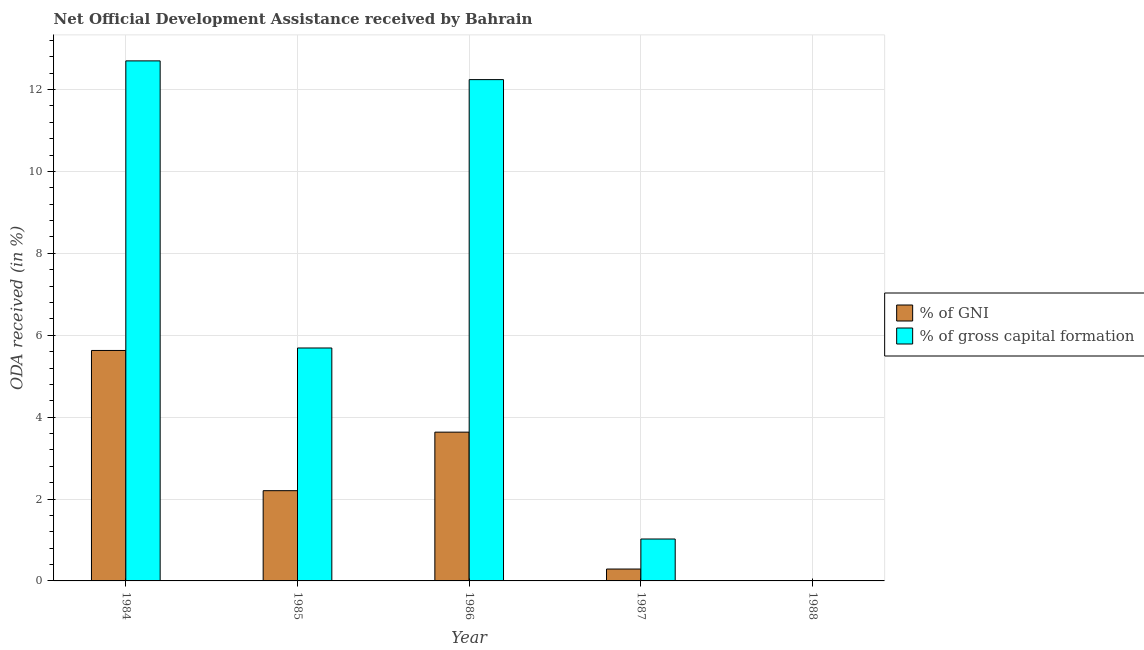How many different coloured bars are there?
Offer a terse response. 2. How many bars are there on the 1st tick from the left?
Provide a succinct answer. 2. What is the label of the 1st group of bars from the left?
Make the answer very short. 1984. In how many cases, is the number of bars for a given year not equal to the number of legend labels?
Make the answer very short. 1. Across all years, what is the maximum oda received as percentage of gross capital formation?
Offer a very short reply. 12.7. What is the total oda received as percentage of gross capital formation in the graph?
Your response must be concise. 31.66. What is the difference between the oda received as percentage of gross capital formation in 1984 and that in 1987?
Provide a short and direct response. 11.68. What is the difference between the oda received as percentage of gni in 1986 and the oda received as percentage of gross capital formation in 1987?
Offer a very short reply. 3.34. What is the average oda received as percentage of gni per year?
Your response must be concise. 2.35. What is the ratio of the oda received as percentage of gross capital formation in 1984 to that in 1987?
Your answer should be compact. 12.41. Is the difference between the oda received as percentage of gross capital formation in 1984 and 1986 greater than the difference between the oda received as percentage of gni in 1984 and 1986?
Your answer should be compact. No. What is the difference between the highest and the second highest oda received as percentage of gni?
Offer a very short reply. 2. What is the difference between the highest and the lowest oda received as percentage of gross capital formation?
Give a very brief answer. 12.7. What is the difference between two consecutive major ticks on the Y-axis?
Your answer should be very brief. 2. Are the values on the major ticks of Y-axis written in scientific E-notation?
Your answer should be very brief. No. Does the graph contain any zero values?
Provide a short and direct response. Yes. Where does the legend appear in the graph?
Your answer should be compact. Center right. How are the legend labels stacked?
Keep it short and to the point. Vertical. What is the title of the graph?
Ensure brevity in your answer.  Net Official Development Assistance received by Bahrain. Does "Females" appear as one of the legend labels in the graph?
Offer a terse response. No. What is the label or title of the X-axis?
Keep it short and to the point. Year. What is the label or title of the Y-axis?
Keep it short and to the point. ODA received (in %). What is the ODA received (in %) of % of GNI in 1984?
Your answer should be very brief. 5.63. What is the ODA received (in %) in % of gross capital formation in 1984?
Offer a terse response. 12.7. What is the ODA received (in %) in % of GNI in 1985?
Ensure brevity in your answer.  2.2. What is the ODA received (in %) of % of gross capital formation in 1985?
Provide a succinct answer. 5.69. What is the ODA received (in %) in % of GNI in 1986?
Offer a terse response. 3.63. What is the ODA received (in %) in % of gross capital formation in 1986?
Provide a succinct answer. 12.24. What is the ODA received (in %) of % of GNI in 1987?
Keep it short and to the point. 0.29. What is the ODA received (in %) in % of gross capital formation in 1987?
Make the answer very short. 1.02. What is the ODA received (in %) in % of GNI in 1988?
Your answer should be compact. 0. What is the ODA received (in %) of % of gross capital formation in 1988?
Offer a terse response. 0. Across all years, what is the maximum ODA received (in %) of % of GNI?
Your answer should be compact. 5.63. Across all years, what is the maximum ODA received (in %) in % of gross capital formation?
Your response must be concise. 12.7. Across all years, what is the minimum ODA received (in %) in % of GNI?
Offer a very short reply. 0. Across all years, what is the minimum ODA received (in %) of % of gross capital formation?
Your answer should be very brief. 0. What is the total ODA received (in %) of % of GNI in the graph?
Offer a terse response. 11.76. What is the total ODA received (in %) of % of gross capital formation in the graph?
Your response must be concise. 31.66. What is the difference between the ODA received (in %) in % of GNI in 1984 and that in 1985?
Your response must be concise. 3.42. What is the difference between the ODA received (in %) in % of gross capital formation in 1984 and that in 1985?
Provide a short and direct response. 7.01. What is the difference between the ODA received (in %) of % of GNI in 1984 and that in 1986?
Keep it short and to the point. 2. What is the difference between the ODA received (in %) of % of gross capital formation in 1984 and that in 1986?
Your response must be concise. 0.46. What is the difference between the ODA received (in %) in % of GNI in 1984 and that in 1987?
Your answer should be very brief. 5.34. What is the difference between the ODA received (in %) in % of gross capital formation in 1984 and that in 1987?
Ensure brevity in your answer.  11.68. What is the difference between the ODA received (in %) in % of GNI in 1985 and that in 1986?
Your answer should be very brief. -1.43. What is the difference between the ODA received (in %) of % of gross capital formation in 1985 and that in 1986?
Give a very brief answer. -6.55. What is the difference between the ODA received (in %) of % of GNI in 1985 and that in 1987?
Your answer should be very brief. 1.91. What is the difference between the ODA received (in %) in % of gross capital formation in 1985 and that in 1987?
Give a very brief answer. 4.67. What is the difference between the ODA received (in %) of % of GNI in 1986 and that in 1987?
Your answer should be very brief. 3.34. What is the difference between the ODA received (in %) in % of gross capital formation in 1986 and that in 1987?
Provide a short and direct response. 11.22. What is the difference between the ODA received (in %) in % of GNI in 1984 and the ODA received (in %) in % of gross capital formation in 1985?
Keep it short and to the point. -0.06. What is the difference between the ODA received (in %) of % of GNI in 1984 and the ODA received (in %) of % of gross capital formation in 1986?
Offer a terse response. -6.61. What is the difference between the ODA received (in %) in % of GNI in 1984 and the ODA received (in %) in % of gross capital formation in 1987?
Provide a short and direct response. 4.6. What is the difference between the ODA received (in %) in % of GNI in 1985 and the ODA received (in %) in % of gross capital formation in 1986?
Your answer should be very brief. -10.04. What is the difference between the ODA received (in %) in % of GNI in 1985 and the ODA received (in %) in % of gross capital formation in 1987?
Provide a short and direct response. 1.18. What is the difference between the ODA received (in %) of % of GNI in 1986 and the ODA received (in %) of % of gross capital formation in 1987?
Your answer should be compact. 2.61. What is the average ODA received (in %) of % of GNI per year?
Give a very brief answer. 2.35. What is the average ODA received (in %) in % of gross capital formation per year?
Make the answer very short. 6.33. In the year 1984, what is the difference between the ODA received (in %) in % of GNI and ODA received (in %) in % of gross capital formation?
Make the answer very short. -7.07. In the year 1985, what is the difference between the ODA received (in %) in % of GNI and ODA received (in %) in % of gross capital formation?
Keep it short and to the point. -3.48. In the year 1986, what is the difference between the ODA received (in %) in % of GNI and ODA received (in %) in % of gross capital formation?
Offer a very short reply. -8.61. In the year 1987, what is the difference between the ODA received (in %) of % of GNI and ODA received (in %) of % of gross capital formation?
Provide a succinct answer. -0.73. What is the ratio of the ODA received (in %) of % of GNI in 1984 to that in 1985?
Keep it short and to the point. 2.55. What is the ratio of the ODA received (in %) in % of gross capital formation in 1984 to that in 1985?
Your response must be concise. 2.23. What is the ratio of the ODA received (in %) in % of GNI in 1984 to that in 1986?
Give a very brief answer. 1.55. What is the ratio of the ODA received (in %) in % of gross capital formation in 1984 to that in 1986?
Your answer should be very brief. 1.04. What is the ratio of the ODA received (in %) in % of GNI in 1984 to that in 1987?
Offer a very short reply. 19.39. What is the ratio of the ODA received (in %) of % of gross capital formation in 1984 to that in 1987?
Offer a very short reply. 12.41. What is the ratio of the ODA received (in %) in % of GNI in 1985 to that in 1986?
Keep it short and to the point. 0.61. What is the ratio of the ODA received (in %) of % of gross capital formation in 1985 to that in 1986?
Give a very brief answer. 0.46. What is the ratio of the ODA received (in %) of % of GNI in 1985 to that in 1987?
Your answer should be very brief. 7.59. What is the ratio of the ODA received (in %) in % of gross capital formation in 1985 to that in 1987?
Keep it short and to the point. 5.56. What is the ratio of the ODA received (in %) in % of GNI in 1986 to that in 1987?
Ensure brevity in your answer.  12.52. What is the ratio of the ODA received (in %) of % of gross capital formation in 1986 to that in 1987?
Provide a succinct answer. 11.96. What is the difference between the highest and the second highest ODA received (in %) in % of GNI?
Your response must be concise. 2. What is the difference between the highest and the second highest ODA received (in %) in % of gross capital formation?
Offer a very short reply. 0.46. What is the difference between the highest and the lowest ODA received (in %) in % of GNI?
Your answer should be compact. 5.63. What is the difference between the highest and the lowest ODA received (in %) in % of gross capital formation?
Keep it short and to the point. 12.7. 